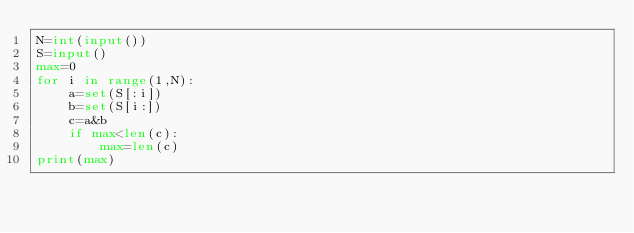<code> <loc_0><loc_0><loc_500><loc_500><_Python_>N=int(input())
S=input()
max=0
for i in range(1,N):
    a=set(S[:i])
    b=set(S[i:])
    c=a&b
    if max<len(c):
        max=len(c)
print(max)</code> 